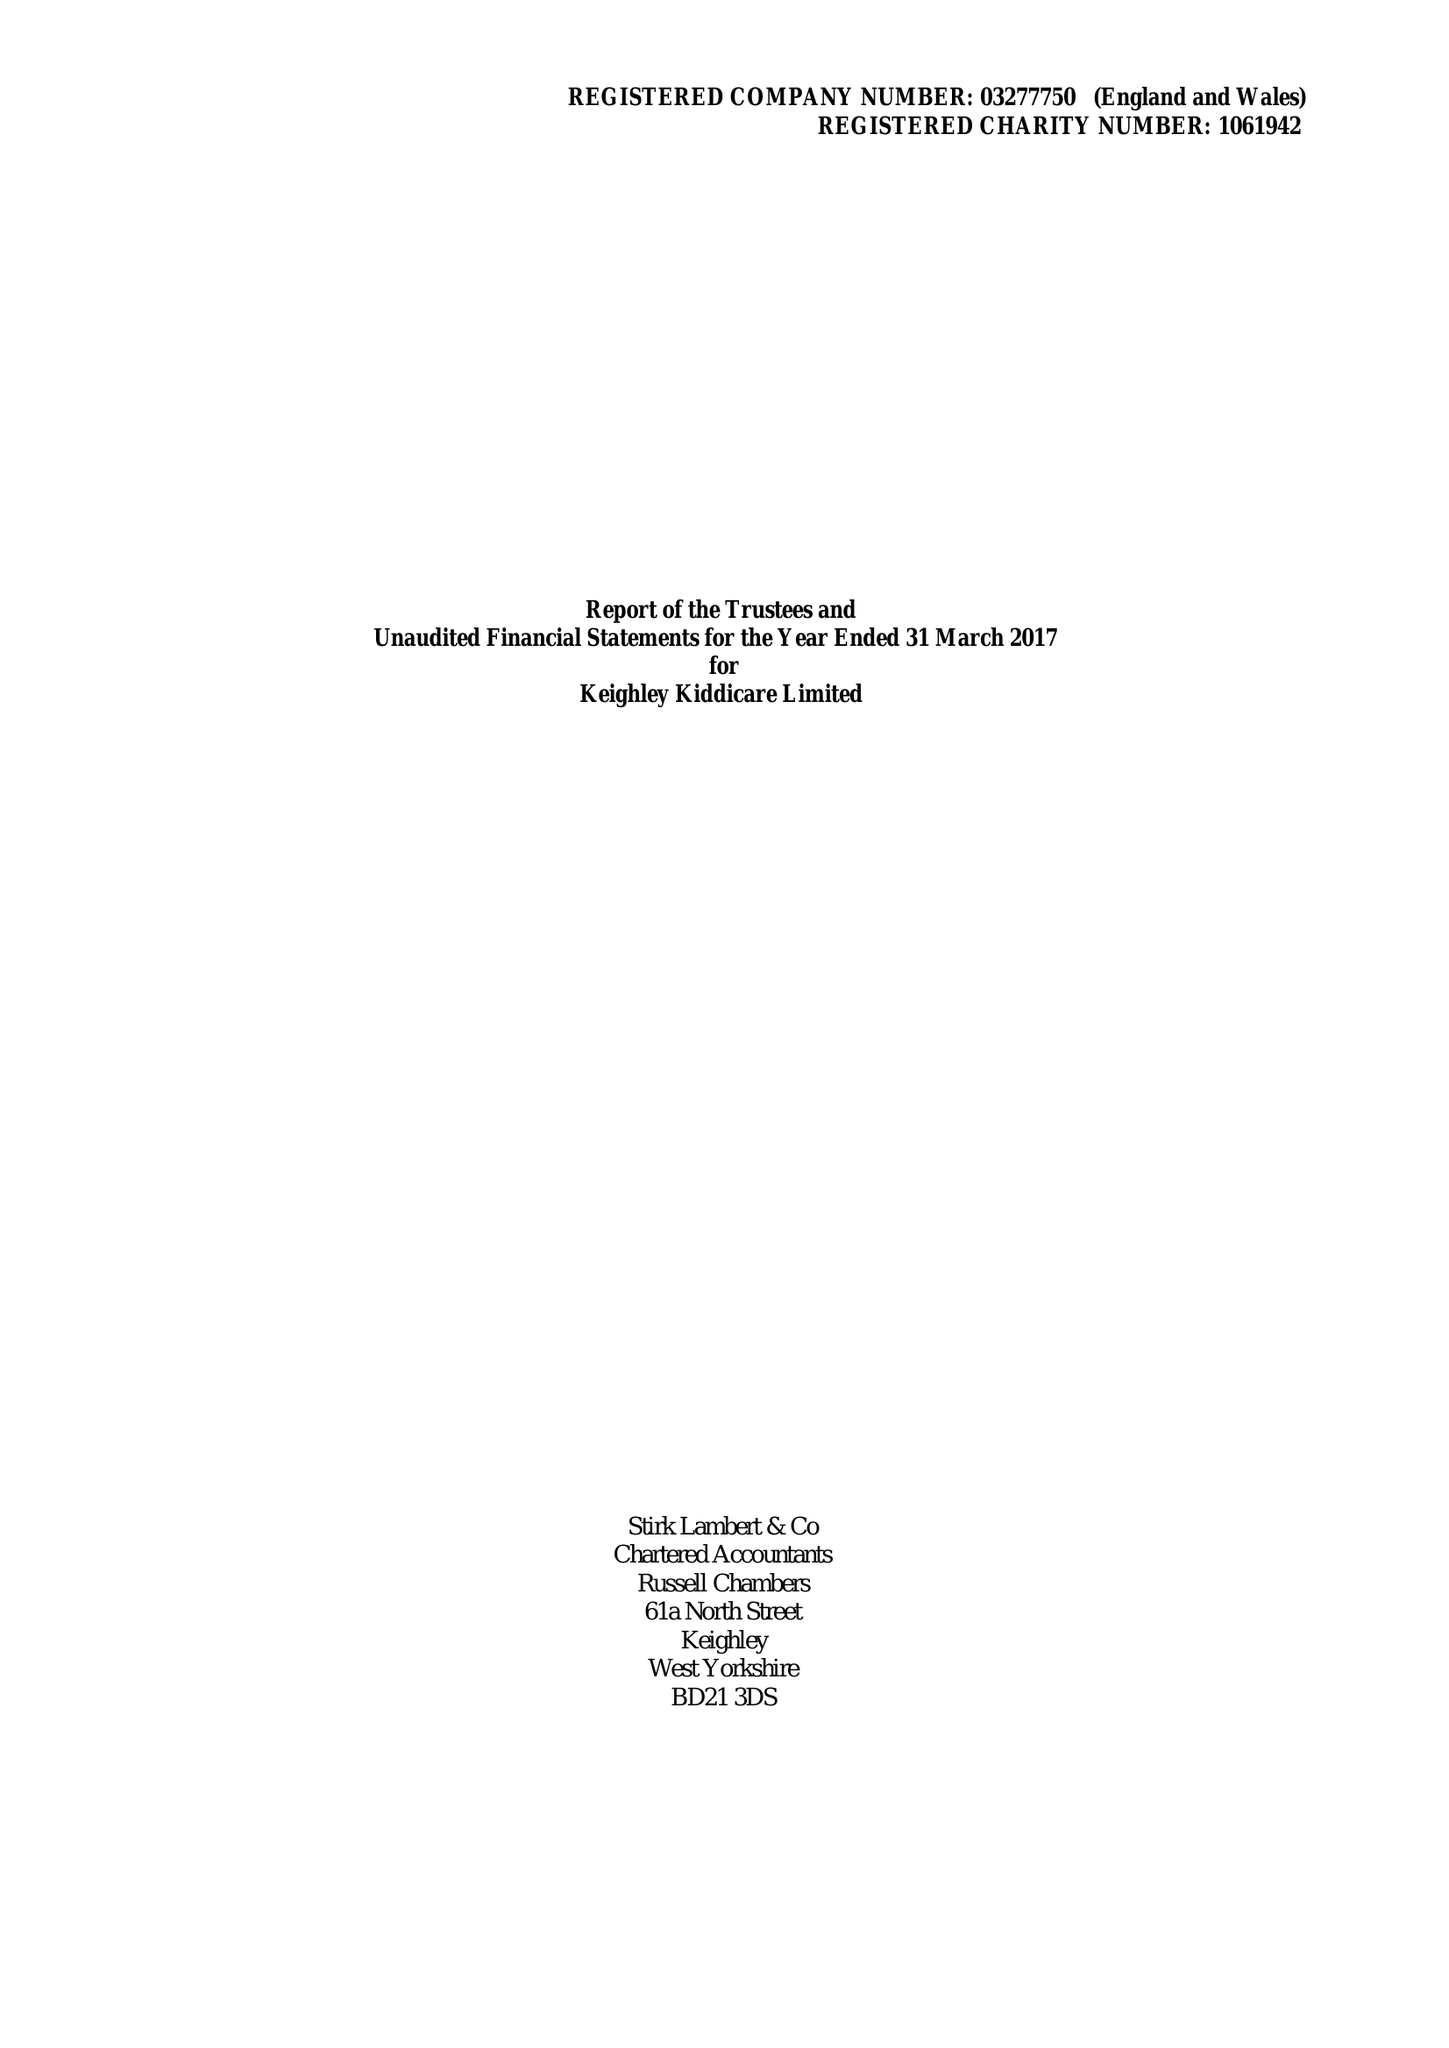What is the value for the income_annually_in_british_pounds?
Answer the question using a single word or phrase. 414880.00 